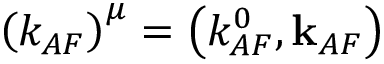Convert formula to latex. <formula><loc_0><loc_0><loc_500><loc_500>\left ( k _ { A F } \right ) ^ { \mu } = \left ( k _ { A F } ^ { 0 } , { k } _ { A F } \right )</formula> 